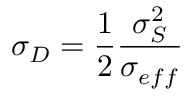Convert formula to latex. <formula><loc_0><loc_0><loc_500><loc_500>\sigma _ { D } = \frac { 1 } { 2 } \frac { \sigma _ { S } ^ { 2 } } { \sigma _ { e f f } }</formula> 